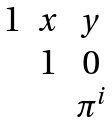Convert formula to latex. <formula><loc_0><loc_0><loc_500><loc_500>\begin{matrix} 1 & x & y \\ & 1 & 0 \\ & & \pi ^ { i } \end{matrix}</formula> 